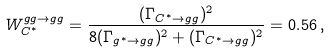<formula> <loc_0><loc_0><loc_500><loc_500>W _ { C ^ { * } } ^ { g g \to g g } = \frac { ( \Gamma _ { C ^ { * } \to g g } ) ^ { 2 } } { 8 ( \Gamma _ { g ^ { * } \to g g } ) ^ { 2 } + ( \Gamma _ { C ^ { * } \to g g } ) ^ { 2 } } = 0 . 5 6 \, ,</formula> 